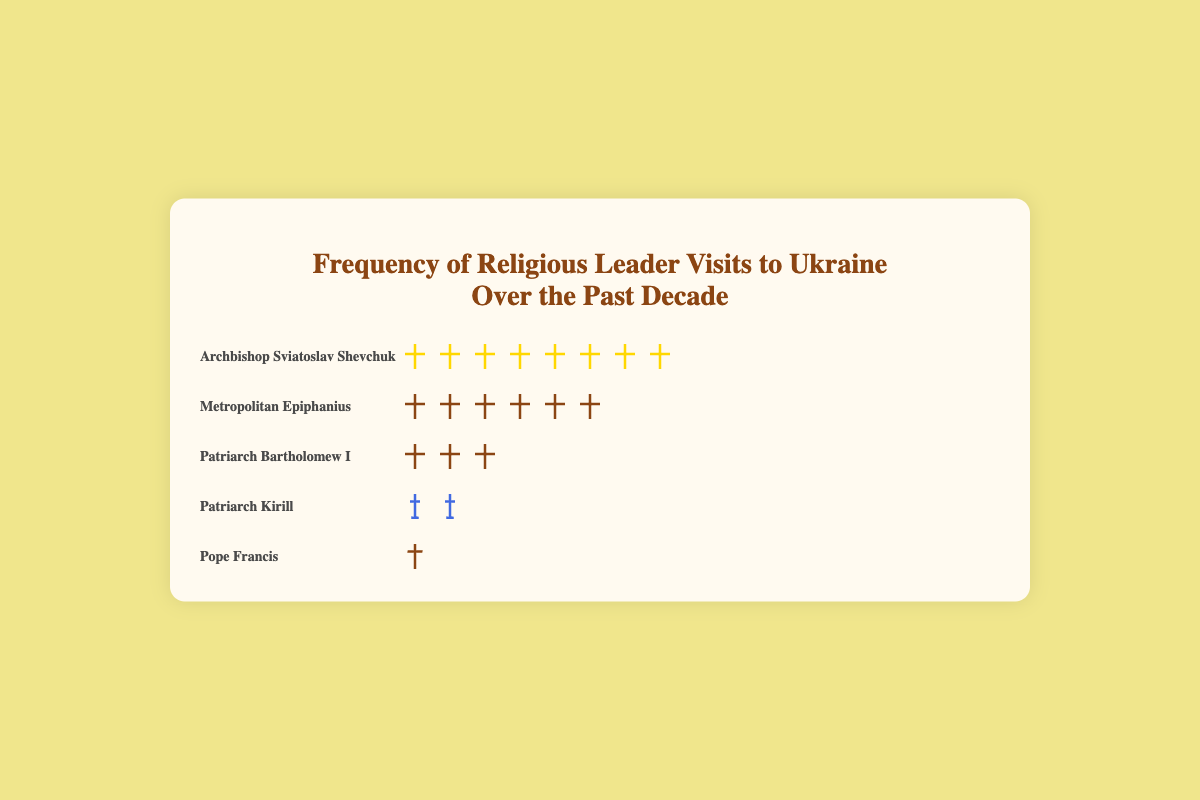Which religious leader has visited Ukraine the most frequently? By examining the number of icons representing visits for each leader, it is clear that Archbishop Sviatoslav Shevchuk has the most icons displayed alongside his name.
Answer: Archbishop Sviatoslav Shevchuk How many times has Metropolitan Epiphanius visited Ukraine? The number of icons next to Metropolitan Epiphanius represents the number of visits. Counting the icons, there are six of them.
Answer: 6 Who has visited Ukraine more frequently: Patriarch Bartholomew I or Pope Francis? By comparing the number of icons next to Patriarch Bartholomew I and Pope Francis, we see that Bartholomew I has 3 icons, whereas Pope Francis has only 1.
Answer: Patriarch Bartholomew I Combined, how many times have Patriarch Kirill and Patriarch Bartholomew I visited Ukraine? Count the icons for Patriarch Kirill (2 icons) and Patriarch Bartholomew I (3 icons). The total is the sum of these visits: 2 + 3 = 5.
Answer: 5 What's the total number of religious leader visits to Ukraine over the past decade? Sum the number of icons for all leaders: 8 (Archbishop Sviatoslav Shevchuk) + 6 (Metropolitan Epiphanius) + 3 (Patriarch Bartholomew I) + 2 (Patriarch Kirill) + 1 (Pope Francis) = 20.
Answer: 20 Which leader's icon is represented by a gold cross? Identify the leader associated with the gold cross icon by matching the icon description in the code: Ukrainian cross (gold) corresponds to Archbishop Sviatoslav Shevchuk.
Answer: Archbishop Sviatoslav Shevchuk Who has the second-highest number of visits to Ukraine? Compare the number of visit icons for all leaders. The second-highest number of visits is represented by Metropolitan Epiphanius with 6 visits.
Answer: Metropolitan Epiphanius How many more visits did Archbishop Sviatoslav Shevchuk make compared to Pope Francis? Count the number of icons for both leaders: 8 (Archbishop Sviatoslav Shevchuk) and 1 (Pope Francis). Subtract the lower number from the higher number: 8 - 1 = 7.
Answer: 7 Which religious leader with an Orthodox cross icon has made fewer visits, and how many visits did they make? Compare the leaders with an Orthodox cross icon: Patriarch Bartholomew I (3 visits) and Metropolitan Epiphanius (6 visits). Patriarch Bartholomew I has fewer visits.
Answer: Patriarch Bartholomew I, 3 